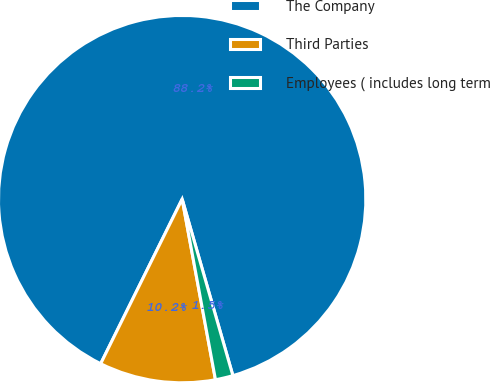Convert chart. <chart><loc_0><loc_0><loc_500><loc_500><pie_chart><fcel>The Company<fcel>Third Parties<fcel>Employees ( includes long term<nl><fcel>88.23%<fcel>10.22%<fcel>1.55%<nl></chart> 